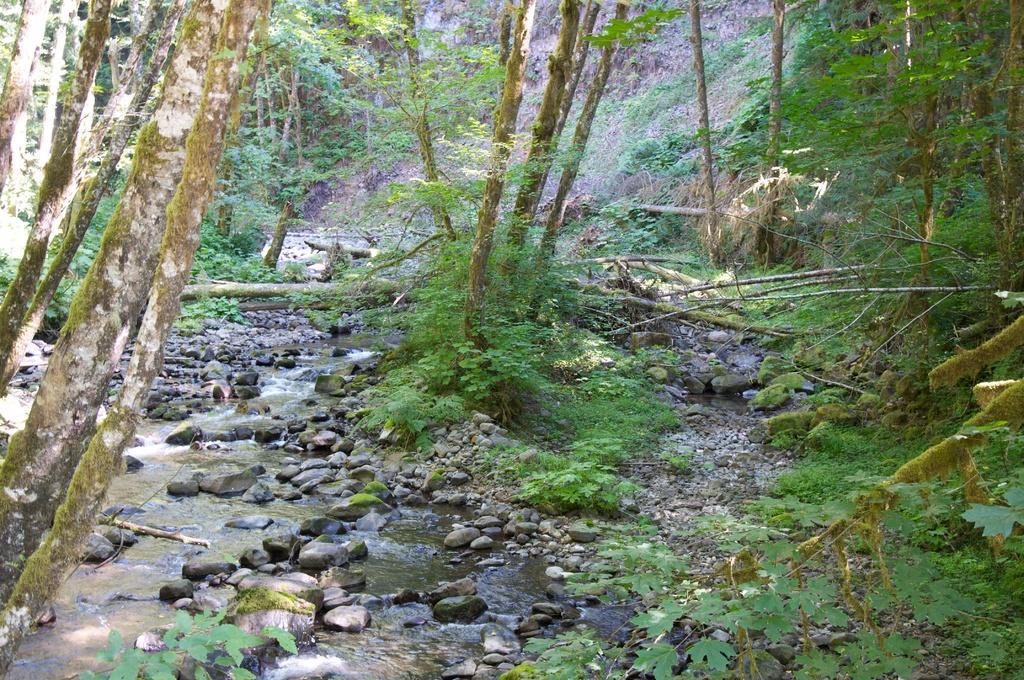In one or two sentences, can you explain what this image depicts? There are water and there are few rocks in between it and there are trees around it. 